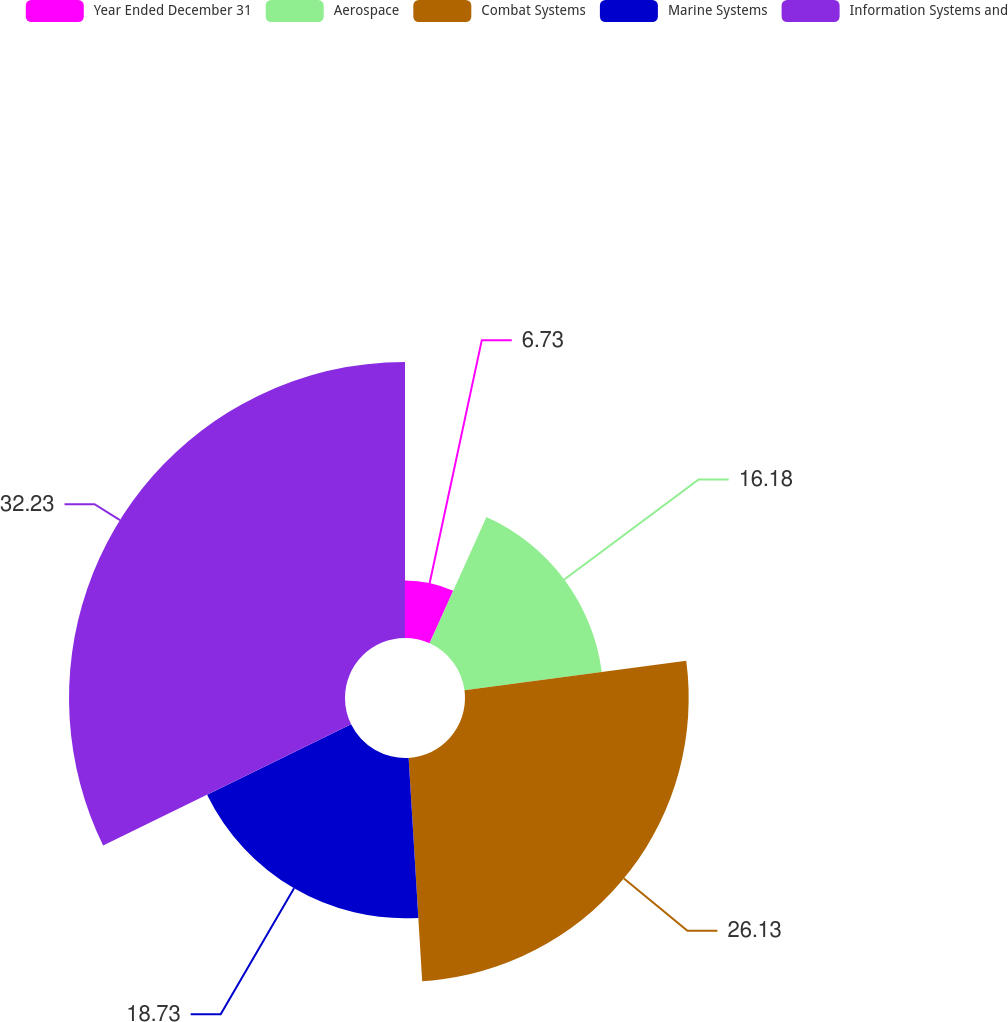<chart> <loc_0><loc_0><loc_500><loc_500><pie_chart><fcel>Year Ended December 31<fcel>Aerospace<fcel>Combat Systems<fcel>Marine Systems<fcel>Information Systems and<nl><fcel>6.73%<fcel>16.18%<fcel>26.13%<fcel>18.73%<fcel>32.24%<nl></chart> 